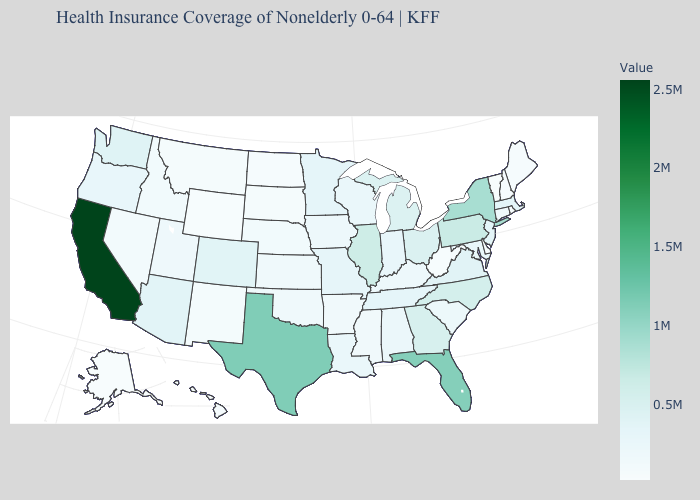Which states have the lowest value in the Northeast?
Answer briefly. Vermont. Does California have the highest value in the USA?
Concise answer only. Yes. Which states have the lowest value in the USA?
Keep it brief. Alaska. Which states have the lowest value in the Northeast?
Give a very brief answer. Vermont. Among the states that border Nebraska , does Iowa have the lowest value?
Quick response, please. No. Among the states that border Virginia , which have the lowest value?
Keep it brief. West Virginia. 